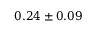<formula> <loc_0><loc_0><loc_500><loc_500>0 . 2 4 \pm 0 . 0 9</formula> 